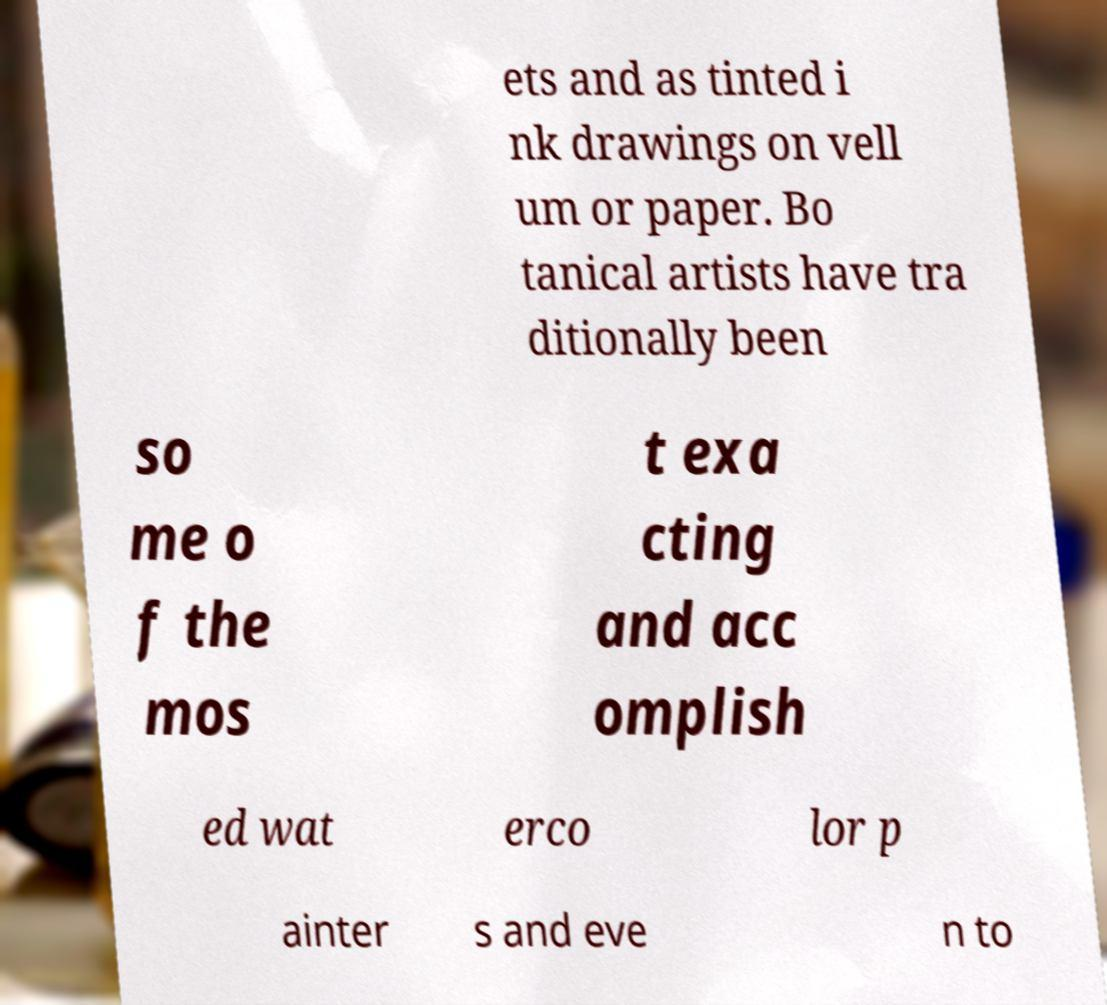I need the written content from this picture converted into text. Can you do that? ets and as tinted i nk drawings on vell um or paper. Bo tanical artists have tra ditionally been so me o f the mos t exa cting and acc omplish ed wat erco lor p ainter s and eve n to 